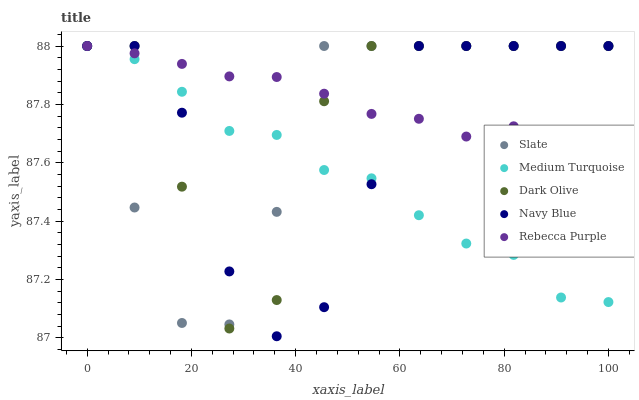Does Medium Turquoise have the minimum area under the curve?
Answer yes or no. Yes. Does Rebecca Purple have the maximum area under the curve?
Answer yes or no. Yes. Does Slate have the minimum area under the curve?
Answer yes or no. No. Does Slate have the maximum area under the curve?
Answer yes or no. No. Is Rebecca Purple the smoothest?
Answer yes or no. Yes. Is Dark Olive the roughest?
Answer yes or no. Yes. Is Slate the smoothest?
Answer yes or no. No. Is Slate the roughest?
Answer yes or no. No. Does Navy Blue have the lowest value?
Answer yes or no. Yes. Does Slate have the lowest value?
Answer yes or no. No. Does Medium Turquoise have the highest value?
Answer yes or no. Yes. Does Navy Blue intersect Medium Turquoise?
Answer yes or no. Yes. Is Navy Blue less than Medium Turquoise?
Answer yes or no. No. Is Navy Blue greater than Medium Turquoise?
Answer yes or no. No. 